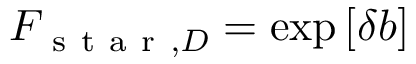<formula> <loc_0><loc_0><loc_500><loc_500>F _ { s t a r , D } = \exp \left [ \delta b \right ]</formula> 